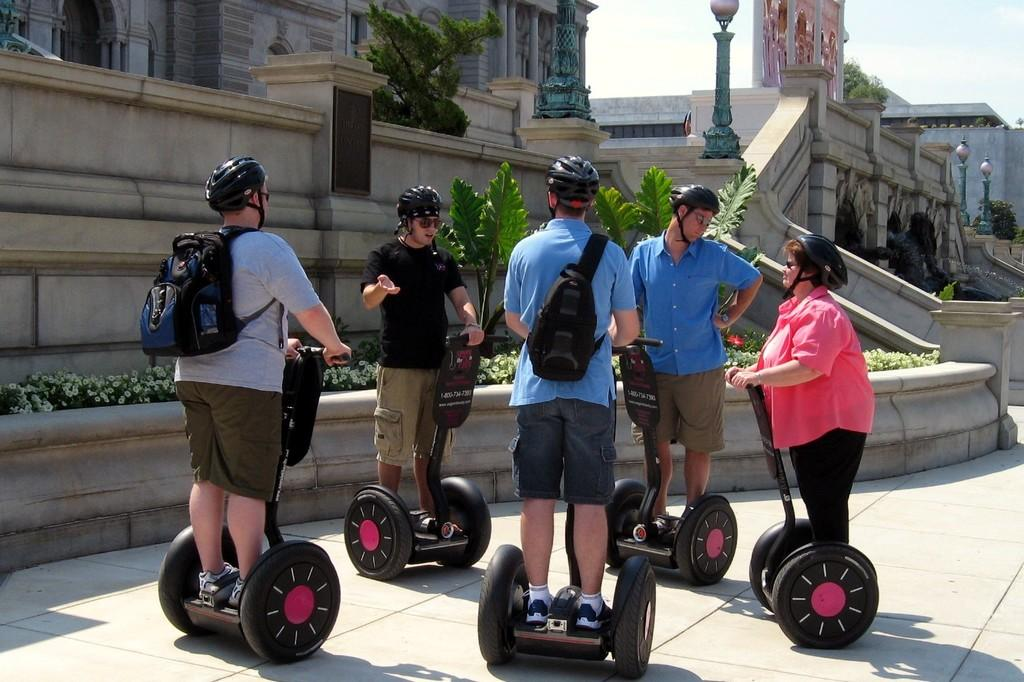How many people are in the image? There is a group of people in the image. What are the people wearing on their heads? The people are wearing helmets. What are the people doing in the image? The people are riding seaways. What type of vegetation can be seen in the image? There are flowers, plants, and trees in the image. What type of structures can be seen in the image? There are buildings in the image. What is visible at the top of the image? The sky is visible at the top of the image. What type of agreement is being discussed by the people in the image? There is no indication in the image that the people are discussing any agreements. 